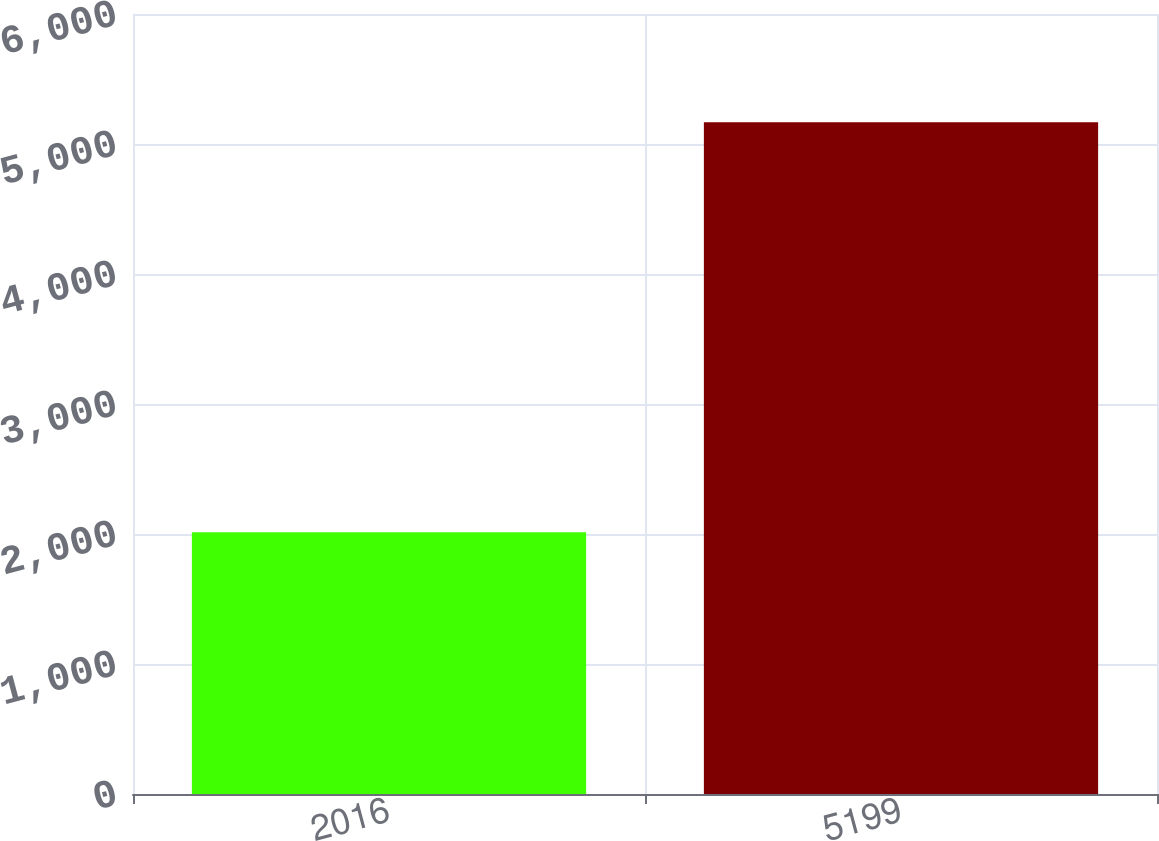<chart> <loc_0><loc_0><loc_500><loc_500><bar_chart><fcel>2016<fcel>5199<nl><fcel>2014<fcel>5168<nl></chart> 